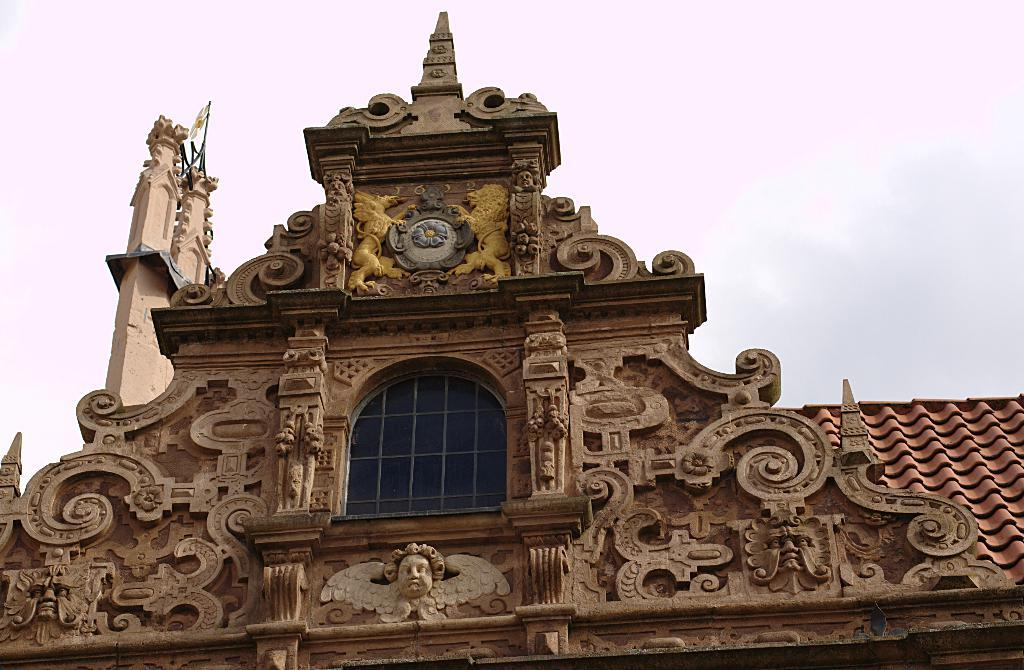What is the main subject of the image? The image depicts the construction of a holy place. What type of windows can be seen in the image? There are glass windows in the image. Are there any statues present in the image? Yes, there are statues in the image. What is visible in the background of the image? The sky is visible in the image. Can you describe the weather conditions in the image? Clouds are present in the sky, suggesting partly cloudy weather. What attempt is being made to hear the pot in the image? There is no pot or attempt to hear it in the image. 